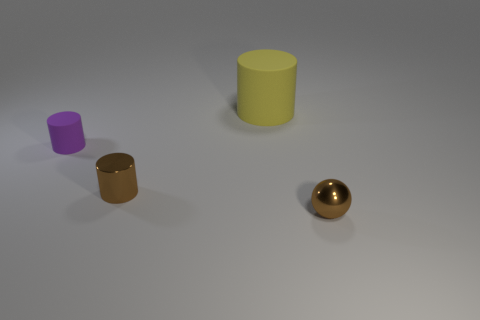What is the shape of the tiny object that is the same color as the metallic cylinder?
Provide a succinct answer. Sphere. Is the color of the metal sphere the same as the metal cylinder?
Your answer should be very brief. Yes. There is a shiny object that is the same shape as the big matte thing; what is its color?
Give a very brief answer. Brown. Is there any other thing that has the same size as the yellow cylinder?
Provide a succinct answer. No. How many other objects are there of the same color as the small metallic sphere?
Your answer should be very brief. 1. What is the shape of the purple rubber thing?
Provide a short and direct response. Cylinder. There is a thing that is behind the matte object that is on the left side of the yellow matte thing; what is it made of?
Your response must be concise. Rubber. How many other objects are the same material as the large cylinder?
Offer a very short reply. 1. What material is the ball that is the same size as the purple object?
Ensure brevity in your answer.  Metal. Is the number of purple matte objects to the right of the big yellow rubber object greater than the number of small brown cylinders right of the small brown ball?
Offer a terse response. No. 